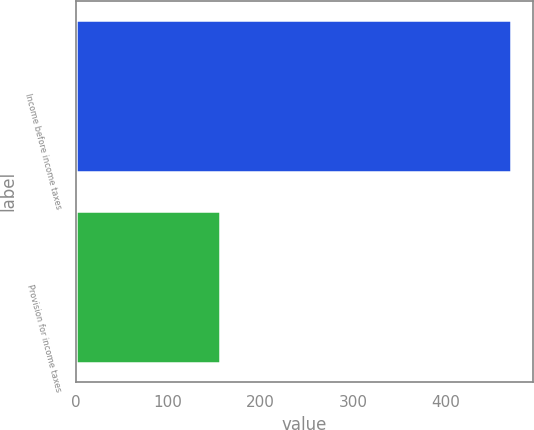Convert chart to OTSL. <chart><loc_0><loc_0><loc_500><loc_500><bar_chart><fcel>Income before income taxes<fcel>Provision for income taxes<nl><fcel>471.5<fcel>156.6<nl></chart> 